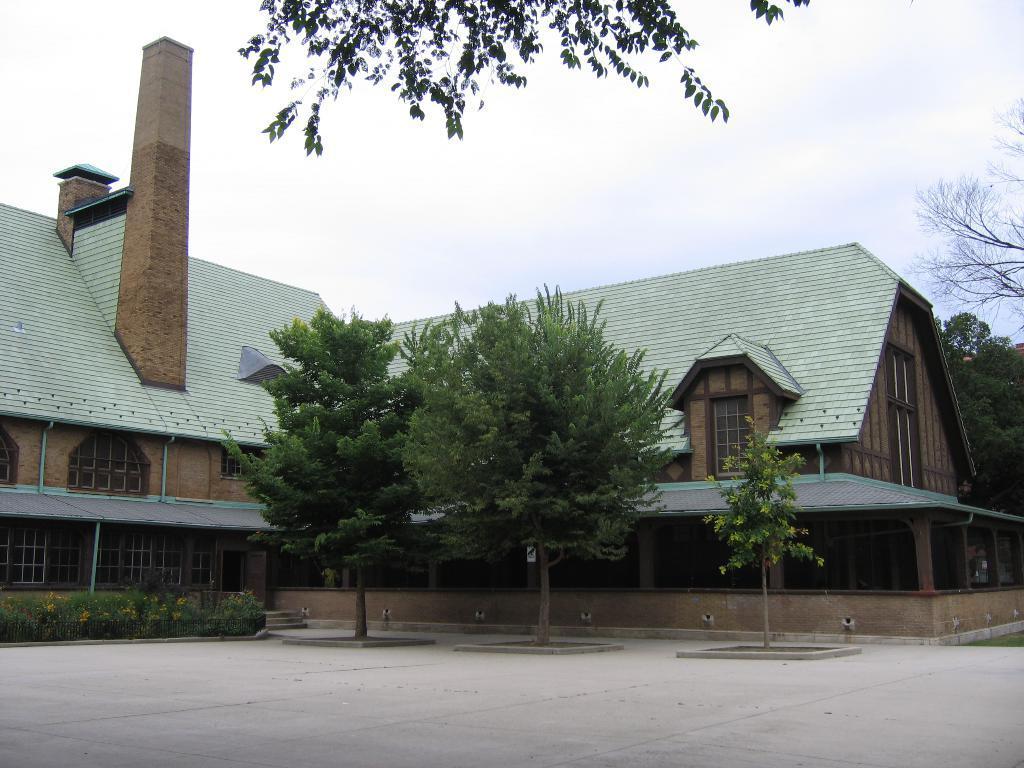In one or two sentences, can you explain what this image depicts? Here in this picture we can see a house present and we can see windows on it over there and we can also see plants and trees present over there and we can see clouds in the sky. 